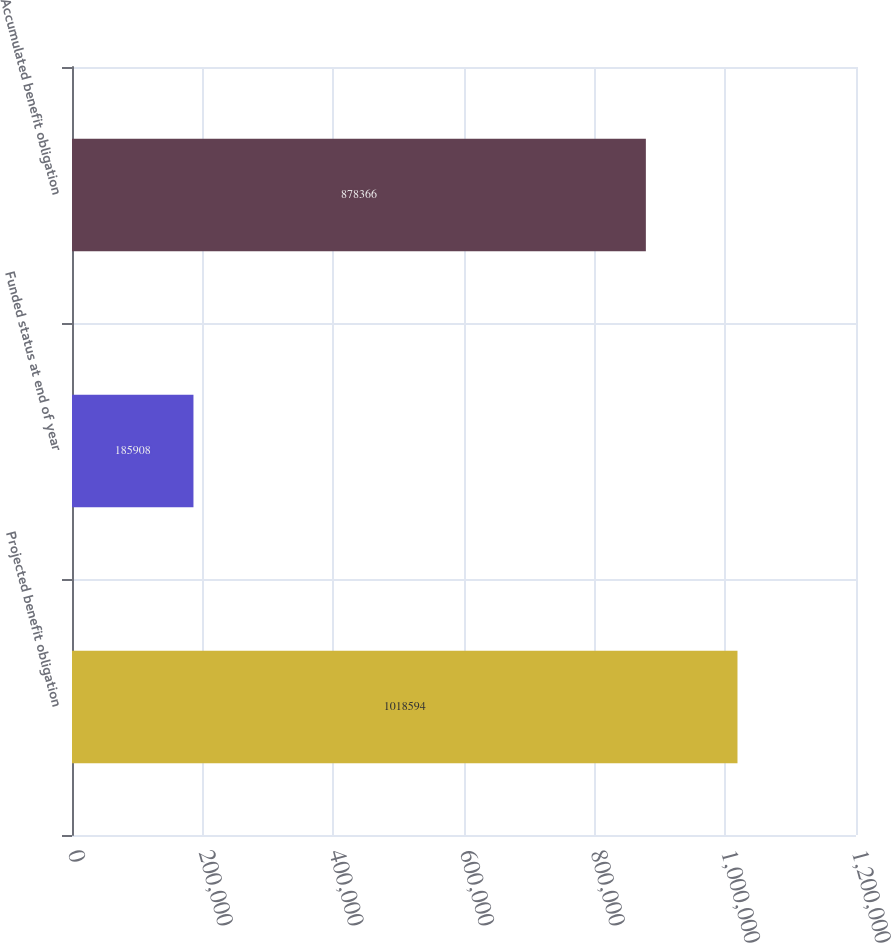Convert chart to OTSL. <chart><loc_0><loc_0><loc_500><loc_500><bar_chart><fcel>Projected benefit obligation<fcel>Funded status at end of year<fcel>Accumulated benefit obligation<nl><fcel>1.01859e+06<fcel>185908<fcel>878366<nl></chart> 